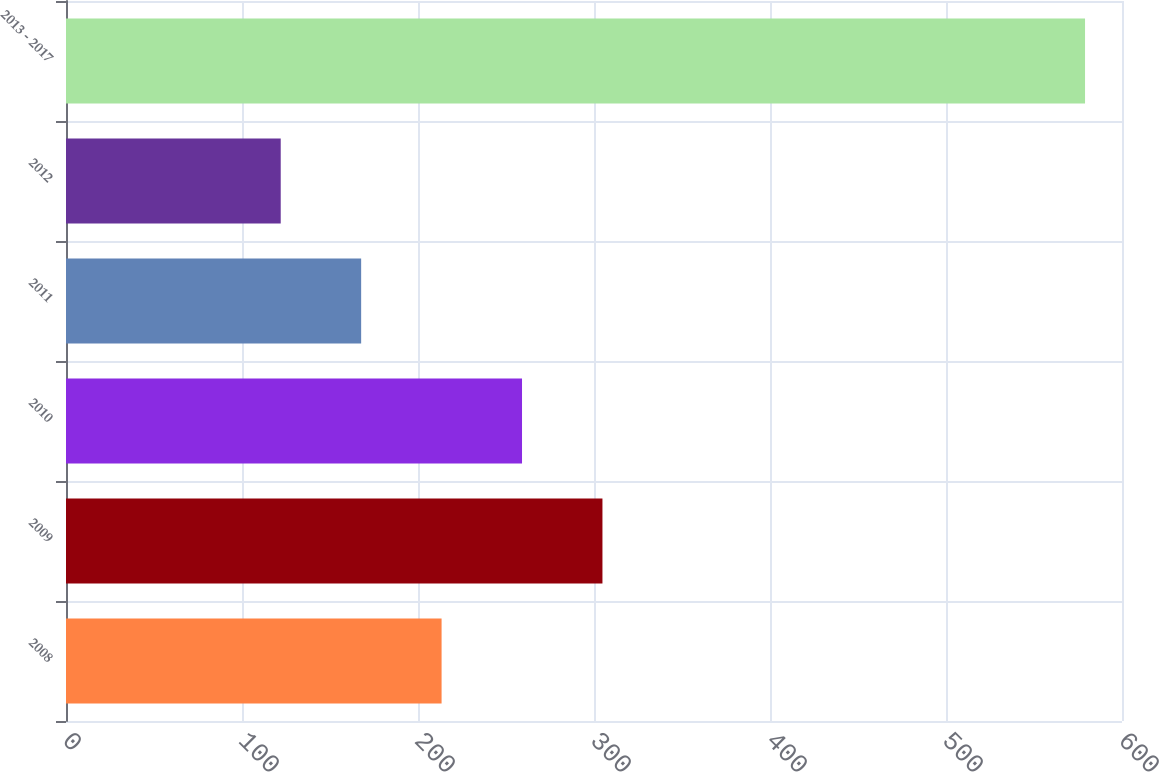Convert chart. <chart><loc_0><loc_0><loc_500><loc_500><bar_chart><fcel>2008<fcel>2009<fcel>2010<fcel>2011<fcel>2012<fcel>2013 - 2017<nl><fcel>213.4<fcel>304.8<fcel>259.1<fcel>167.7<fcel>122<fcel>579<nl></chart> 